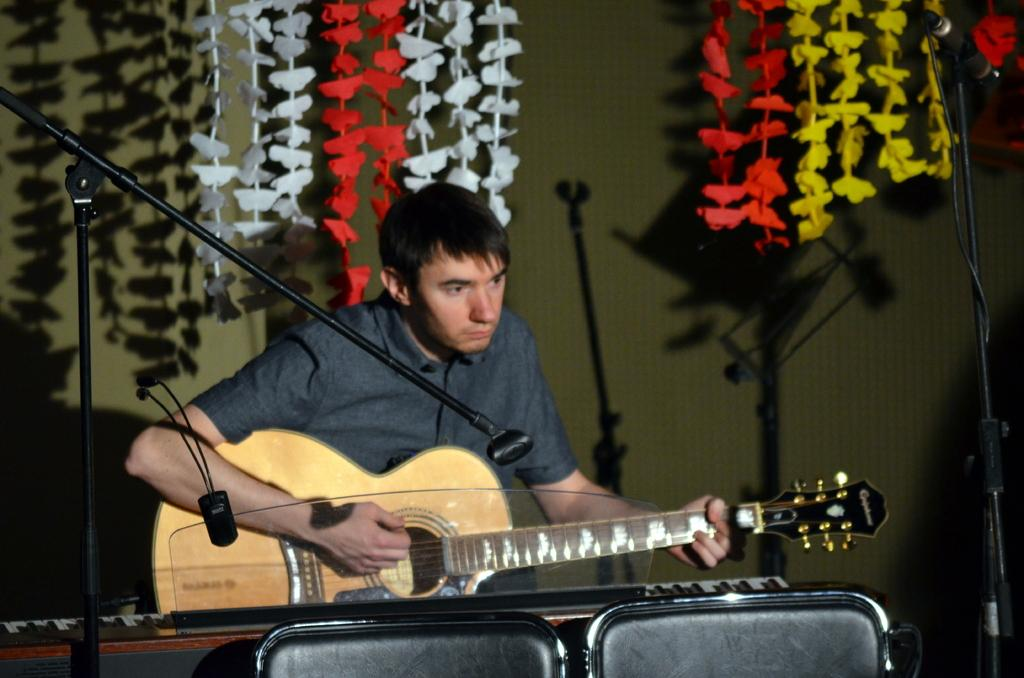What is the man in the image holding? The man is holding a guitar. What is in front of the man? There is equipment in front of the man. What can be seen in the background of the image? There is decoration in the background of the image. What is the man likely to use along with the guitar? There is a microphone in the image, which the man might use for singing. How much sleet is visible on the man's nose in the image? There is no sleet visible on the man's nose in the image, as the facts provided do not mention any weather conditions or the man's nose. 